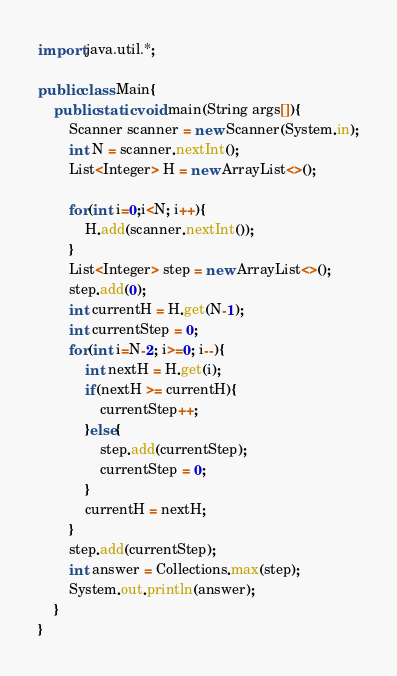<code> <loc_0><loc_0><loc_500><loc_500><_Java_>import java.util.*;

public class Main{
    public static void main(String args[]){
        Scanner scanner = new Scanner(System.in);
        int N = scanner.nextInt();
        List<Integer> H = new ArrayList<>();

        for(int i=0;i<N; i++){
            H.add(scanner.nextInt());
        }
        List<Integer> step = new ArrayList<>();
        step.add(0);
        int currentH = H.get(N-1);
        int currentStep = 0;
        for(int i=N-2; i>=0; i--){
            int nextH = H.get(i);
            if(nextH >= currentH){
                currentStep++;
            }else{
                step.add(currentStep);
                currentStep = 0;
            }
            currentH = nextH;
        }
        step.add(currentStep);
        int answer = Collections.max(step);
        System.out.println(answer);
    }
}</code> 